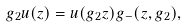Convert formula to latex. <formula><loc_0><loc_0><loc_500><loc_500>g _ { 2 } u ( z ) = u ( g _ { 2 } z ) g _ { - } ( z , g _ { 2 } ) ,</formula> 